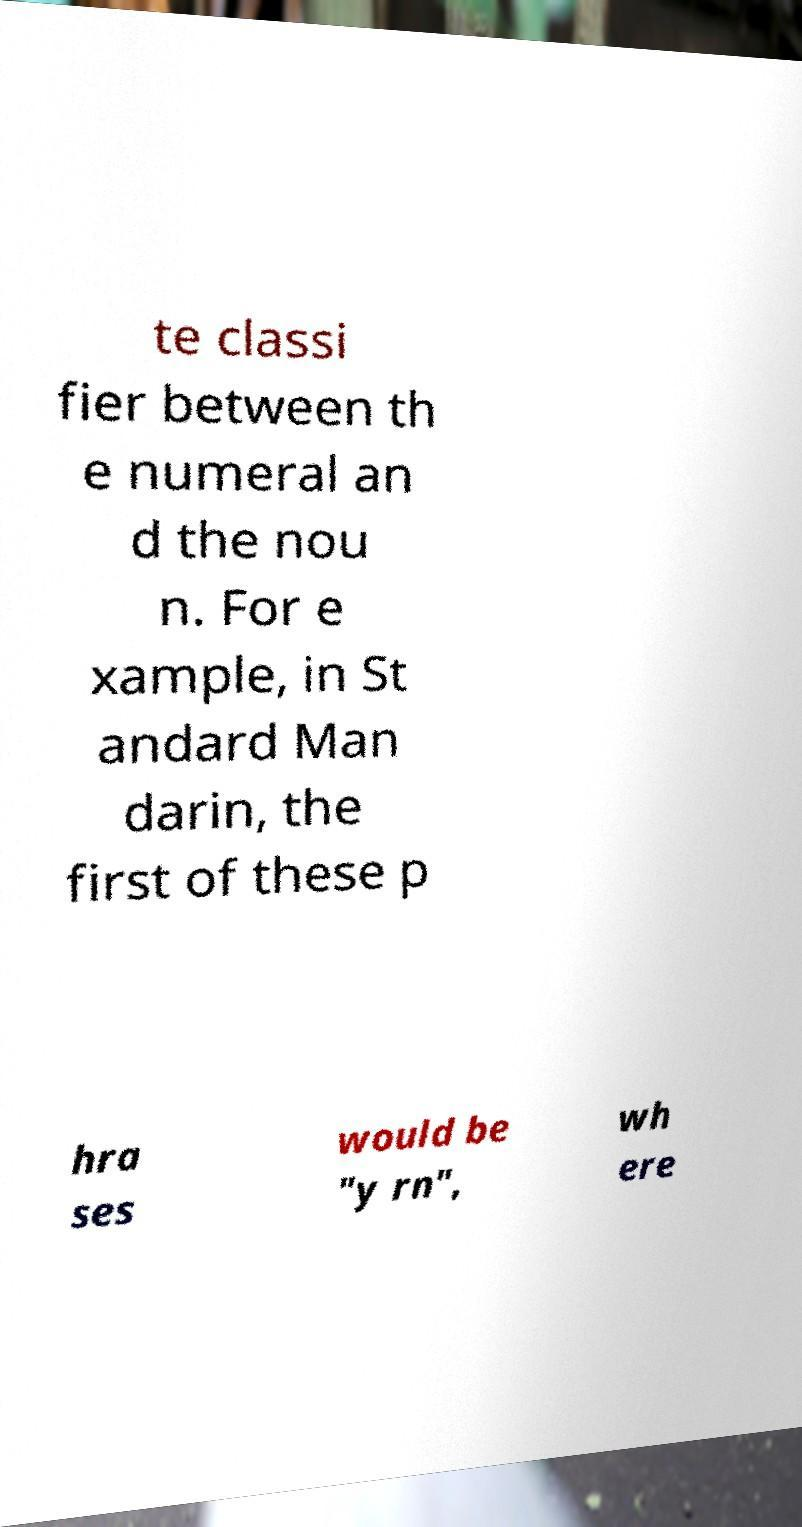Please read and relay the text visible in this image. What does it say? te classi fier between th e numeral an d the nou n. For e xample, in St andard Man darin, the first of these p hra ses would be "y rn", wh ere 